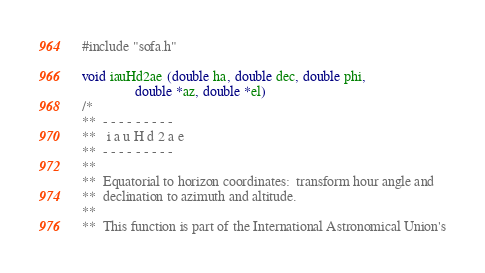<code> <loc_0><loc_0><loc_500><loc_500><_C_>#include "sofa.h"

void iauHd2ae (double ha, double dec, double phi,
               double *az, double *el)
/*
**  - - - - - - - - -
**   i a u H d 2 a e
**  - - - - - - - - -
**
**  Equatorial to horizon coordinates:  transform hour angle and
**  declination to azimuth and altitude.
**
**  This function is part of the International Astronomical Union's</code> 